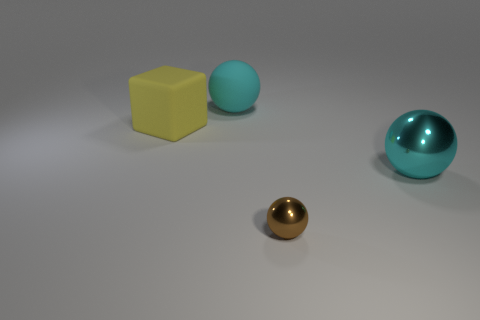What number of other things are made of the same material as the cube?
Provide a succinct answer. 1. What number of other things are there of the same color as the large matte ball?
Offer a terse response. 1. Is the number of yellow matte blocks that are on the right side of the large cyan metal object the same as the number of big yellow cubes?
Offer a very short reply. No. What number of large rubber balls are in front of the cyan sphere on the right side of the cyan object behind the big yellow rubber thing?
Offer a very short reply. 0. Are there any other things that are the same size as the brown thing?
Your response must be concise. No. There is a yellow cube; is its size the same as the cyan sphere that is behind the cyan shiny sphere?
Your answer should be compact. Yes. How many tiny blue cylinders are there?
Provide a short and direct response. 0. Do the sphere on the right side of the brown thing and the rubber thing right of the yellow object have the same size?
Your response must be concise. Yes. What is the color of the rubber object that is the same shape as the cyan shiny object?
Offer a very short reply. Cyan. Is the cyan matte object the same shape as the small thing?
Your answer should be very brief. Yes. 